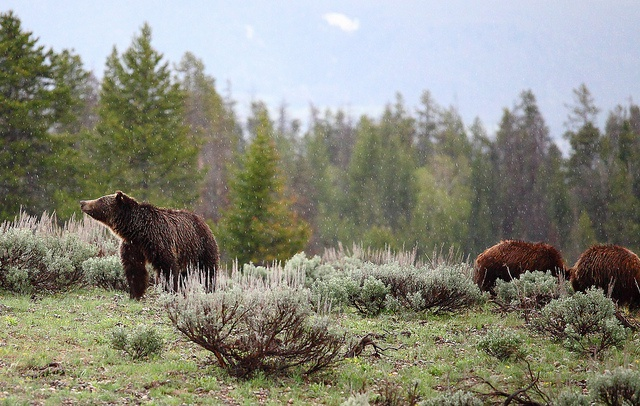Describe the objects in this image and their specific colors. I can see bear in lavender, black, gray, and maroon tones, bear in lavender, black, maroon, gray, and brown tones, and bear in lavender, black, maroon, and gray tones in this image. 